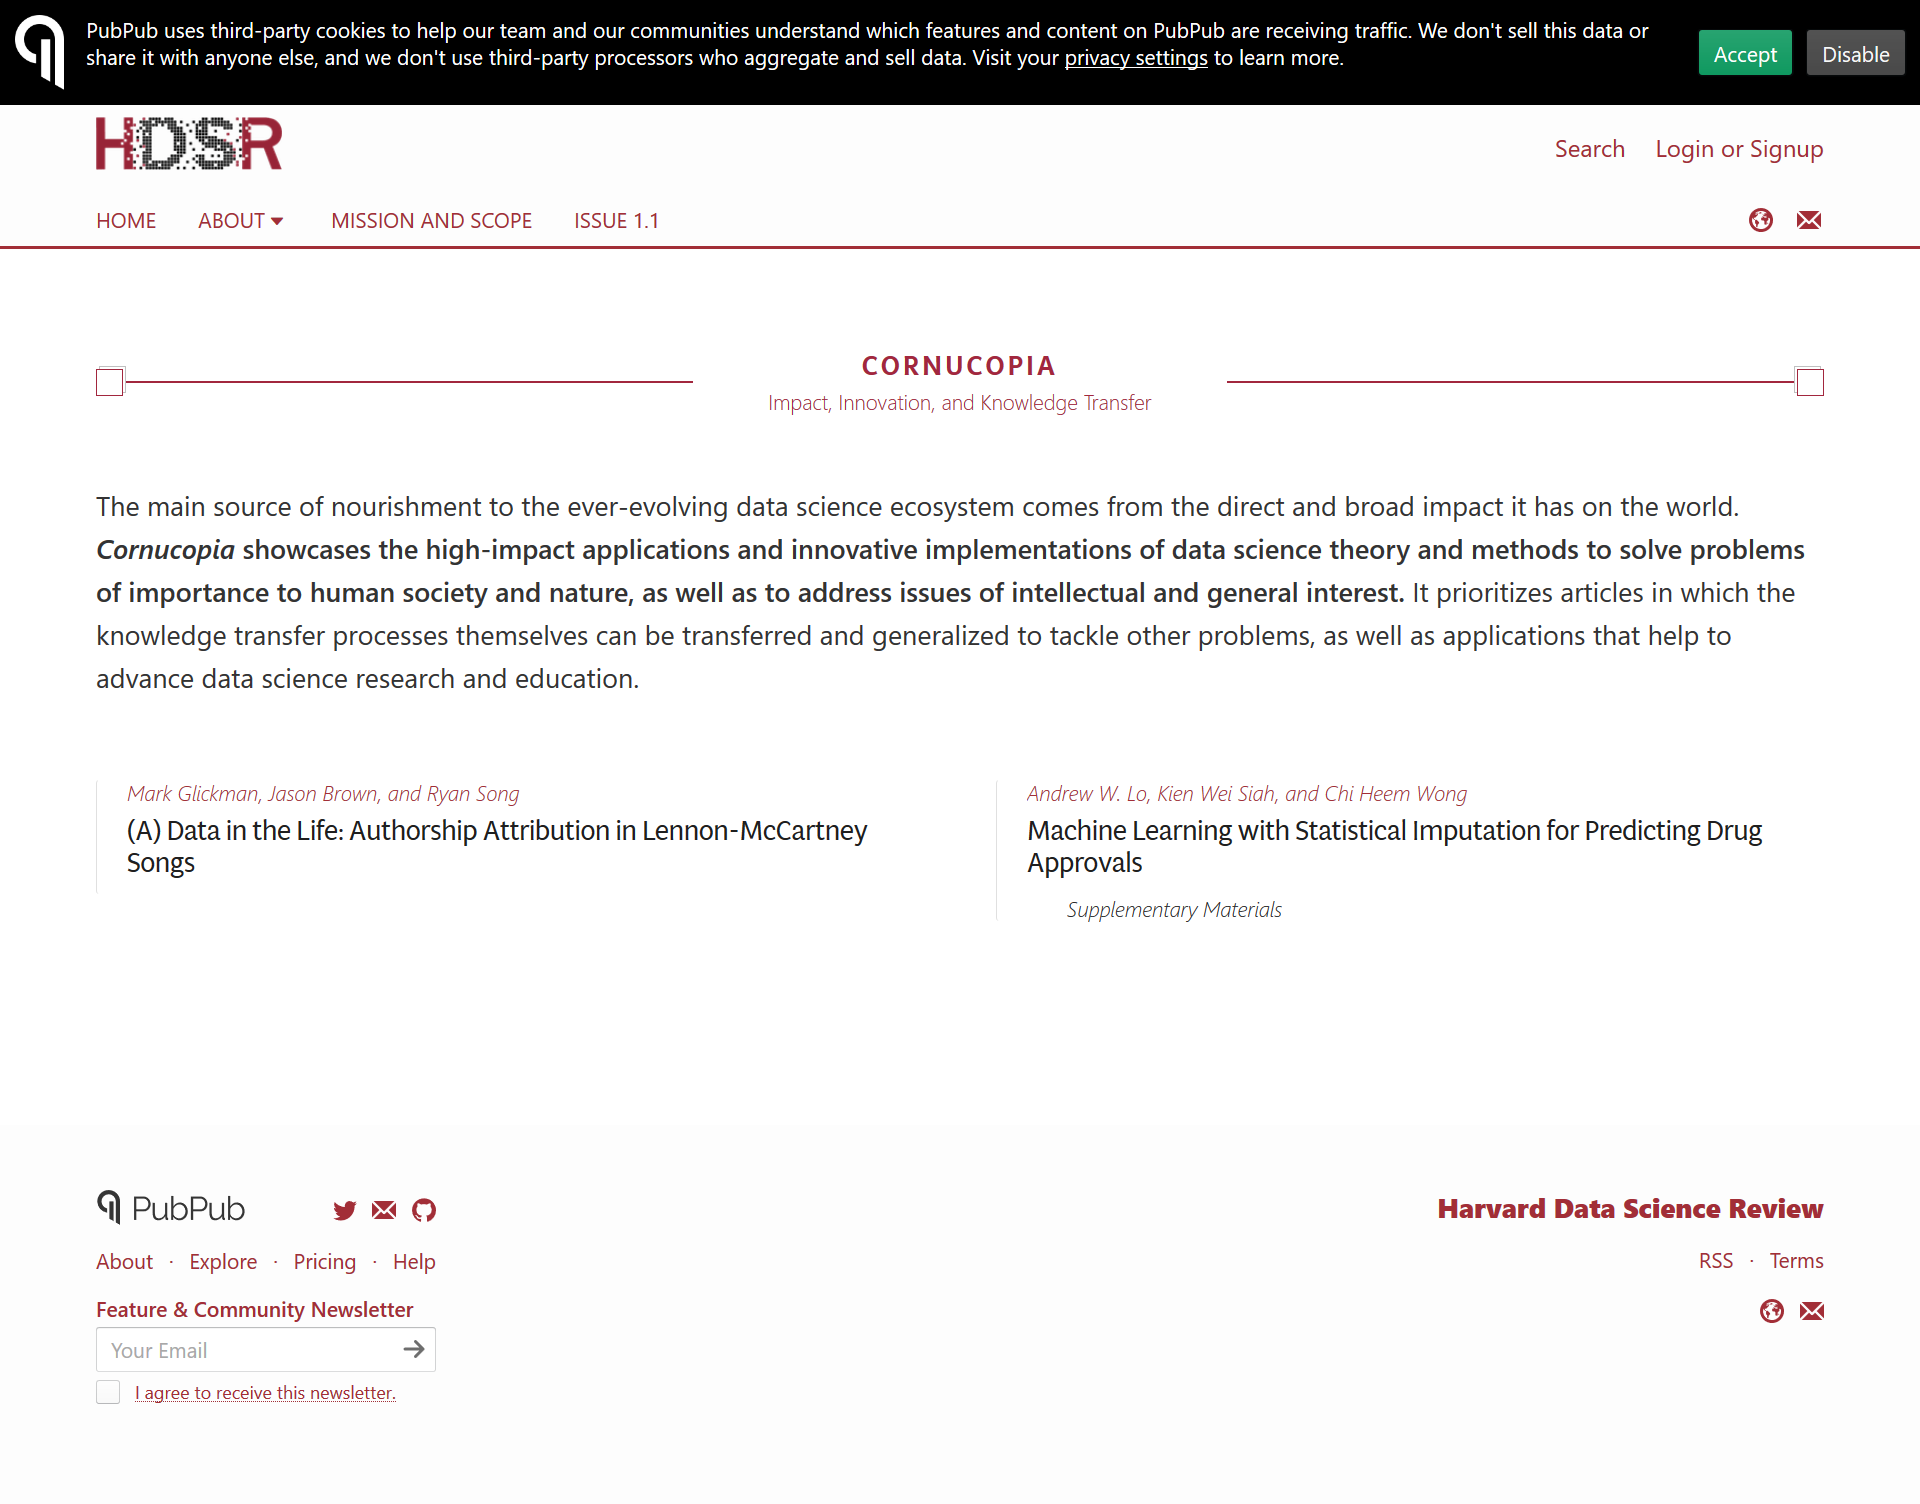Specify some key components in this picture. Cornucopia showcases impact, innovation, and knowledge transfer in three key areas. Lennon-McCartney, the songwriting duo, are mentioned in the reference material. According to the reference materials, a total of six individuals are named: Mark Glickman, Jason Brown, Ryan Song, Andrew W. Lo, Kien Wei Siah, and Chi Heem Wong. 